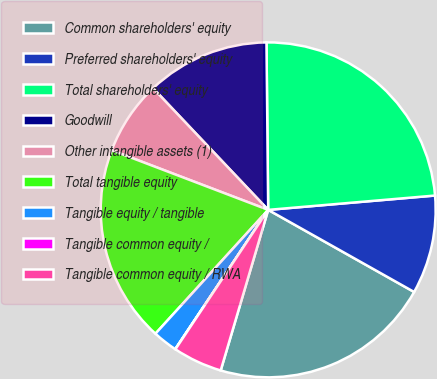<chart> <loc_0><loc_0><loc_500><loc_500><pie_chart><fcel>Common shareholders' equity<fcel>Preferred shareholders' equity<fcel>Total shareholders' equity<fcel>Goodwill<fcel>Other intangible assets (1)<fcel>Total tangible equity<fcel>Tangible equity / tangible<fcel>Tangible common equity /<fcel>Tangible common equity / RWA<nl><fcel>21.42%<fcel>9.52%<fcel>23.8%<fcel>11.9%<fcel>7.14%<fcel>19.04%<fcel>2.39%<fcel>0.02%<fcel>4.77%<nl></chart> 